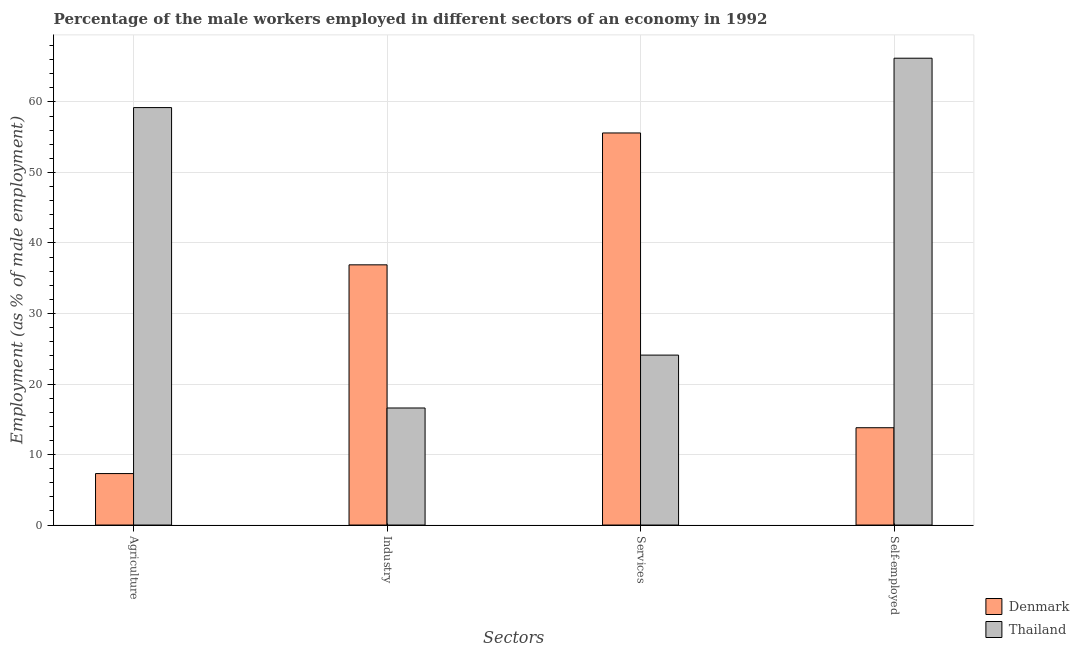How many different coloured bars are there?
Provide a succinct answer. 2. How many groups of bars are there?
Give a very brief answer. 4. Are the number of bars per tick equal to the number of legend labels?
Provide a short and direct response. Yes. Are the number of bars on each tick of the X-axis equal?
Offer a terse response. Yes. What is the label of the 3rd group of bars from the left?
Give a very brief answer. Services. What is the percentage of self employed male workers in Thailand?
Provide a succinct answer. 66.2. Across all countries, what is the maximum percentage of male workers in services?
Your response must be concise. 55.6. Across all countries, what is the minimum percentage of male workers in agriculture?
Your answer should be compact. 7.3. In which country was the percentage of self employed male workers maximum?
Offer a terse response. Thailand. In which country was the percentage of male workers in services minimum?
Your answer should be compact. Thailand. What is the total percentage of male workers in industry in the graph?
Make the answer very short. 53.5. What is the difference between the percentage of male workers in services in Thailand and that in Denmark?
Keep it short and to the point. -31.5. What is the difference between the percentage of male workers in services in Thailand and the percentage of male workers in industry in Denmark?
Give a very brief answer. -12.8. What is the average percentage of male workers in services per country?
Keep it short and to the point. 39.85. What is the difference between the percentage of male workers in services and percentage of male workers in industry in Thailand?
Offer a terse response. 7.5. What is the ratio of the percentage of male workers in services in Thailand to that in Denmark?
Provide a succinct answer. 0.43. Is the difference between the percentage of self employed male workers in Thailand and Denmark greater than the difference between the percentage of male workers in industry in Thailand and Denmark?
Provide a short and direct response. Yes. What is the difference between the highest and the second highest percentage of male workers in agriculture?
Offer a very short reply. 51.9. What is the difference between the highest and the lowest percentage of male workers in industry?
Your response must be concise. 20.3. In how many countries, is the percentage of self employed male workers greater than the average percentage of self employed male workers taken over all countries?
Provide a short and direct response. 1. What does the 1st bar from the left in Self-employed represents?
Provide a short and direct response. Denmark. What does the 1st bar from the right in Agriculture represents?
Offer a very short reply. Thailand. Is it the case that in every country, the sum of the percentage of male workers in agriculture and percentage of male workers in industry is greater than the percentage of male workers in services?
Your response must be concise. No. How many bars are there?
Your answer should be compact. 8. Are all the bars in the graph horizontal?
Make the answer very short. No. What is the difference between two consecutive major ticks on the Y-axis?
Your answer should be compact. 10. Are the values on the major ticks of Y-axis written in scientific E-notation?
Give a very brief answer. No. Does the graph contain any zero values?
Keep it short and to the point. No. Does the graph contain grids?
Offer a very short reply. Yes. Where does the legend appear in the graph?
Keep it short and to the point. Bottom right. How many legend labels are there?
Make the answer very short. 2. What is the title of the graph?
Provide a succinct answer. Percentage of the male workers employed in different sectors of an economy in 1992. Does "Eritrea" appear as one of the legend labels in the graph?
Your answer should be very brief. No. What is the label or title of the X-axis?
Your answer should be very brief. Sectors. What is the label or title of the Y-axis?
Make the answer very short. Employment (as % of male employment). What is the Employment (as % of male employment) in Denmark in Agriculture?
Keep it short and to the point. 7.3. What is the Employment (as % of male employment) of Thailand in Agriculture?
Your answer should be very brief. 59.2. What is the Employment (as % of male employment) in Denmark in Industry?
Your response must be concise. 36.9. What is the Employment (as % of male employment) in Thailand in Industry?
Ensure brevity in your answer.  16.6. What is the Employment (as % of male employment) in Denmark in Services?
Provide a short and direct response. 55.6. What is the Employment (as % of male employment) of Thailand in Services?
Offer a very short reply. 24.1. What is the Employment (as % of male employment) in Denmark in Self-employed?
Offer a terse response. 13.8. What is the Employment (as % of male employment) in Thailand in Self-employed?
Provide a succinct answer. 66.2. Across all Sectors, what is the maximum Employment (as % of male employment) in Denmark?
Make the answer very short. 55.6. Across all Sectors, what is the maximum Employment (as % of male employment) in Thailand?
Offer a terse response. 66.2. Across all Sectors, what is the minimum Employment (as % of male employment) in Denmark?
Make the answer very short. 7.3. Across all Sectors, what is the minimum Employment (as % of male employment) in Thailand?
Offer a terse response. 16.6. What is the total Employment (as % of male employment) of Denmark in the graph?
Give a very brief answer. 113.6. What is the total Employment (as % of male employment) in Thailand in the graph?
Offer a very short reply. 166.1. What is the difference between the Employment (as % of male employment) in Denmark in Agriculture and that in Industry?
Offer a very short reply. -29.6. What is the difference between the Employment (as % of male employment) in Thailand in Agriculture and that in Industry?
Offer a very short reply. 42.6. What is the difference between the Employment (as % of male employment) in Denmark in Agriculture and that in Services?
Give a very brief answer. -48.3. What is the difference between the Employment (as % of male employment) in Thailand in Agriculture and that in Services?
Provide a short and direct response. 35.1. What is the difference between the Employment (as % of male employment) in Denmark in Agriculture and that in Self-employed?
Your answer should be very brief. -6.5. What is the difference between the Employment (as % of male employment) of Denmark in Industry and that in Services?
Your answer should be very brief. -18.7. What is the difference between the Employment (as % of male employment) of Denmark in Industry and that in Self-employed?
Provide a succinct answer. 23.1. What is the difference between the Employment (as % of male employment) in Thailand in Industry and that in Self-employed?
Your response must be concise. -49.6. What is the difference between the Employment (as % of male employment) of Denmark in Services and that in Self-employed?
Offer a terse response. 41.8. What is the difference between the Employment (as % of male employment) of Thailand in Services and that in Self-employed?
Provide a short and direct response. -42.1. What is the difference between the Employment (as % of male employment) in Denmark in Agriculture and the Employment (as % of male employment) in Thailand in Industry?
Provide a short and direct response. -9.3. What is the difference between the Employment (as % of male employment) in Denmark in Agriculture and the Employment (as % of male employment) in Thailand in Services?
Ensure brevity in your answer.  -16.8. What is the difference between the Employment (as % of male employment) of Denmark in Agriculture and the Employment (as % of male employment) of Thailand in Self-employed?
Your answer should be very brief. -58.9. What is the difference between the Employment (as % of male employment) of Denmark in Industry and the Employment (as % of male employment) of Thailand in Self-employed?
Your response must be concise. -29.3. What is the average Employment (as % of male employment) in Denmark per Sectors?
Your answer should be very brief. 28.4. What is the average Employment (as % of male employment) of Thailand per Sectors?
Offer a terse response. 41.52. What is the difference between the Employment (as % of male employment) of Denmark and Employment (as % of male employment) of Thailand in Agriculture?
Offer a terse response. -51.9. What is the difference between the Employment (as % of male employment) in Denmark and Employment (as % of male employment) in Thailand in Industry?
Provide a succinct answer. 20.3. What is the difference between the Employment (as % of male employment) of Denmark and Employment (as % of male employment) of Thailand in Services?
Provide a succinct answer. 31.5. What is the difference between the Employment (as % of male employment) in Denmark and Employment (as % of male employment) in Thailand in Self-employed?
Keep it short and to the point. -52.4. What is the ratio of the Employment (as % of male employment) of Denmark in Agriculture to that in Industry?
Provide a short and direct response. 0.2. What is the ratio of the Employment (as % of male employment) of Thailand in Agriculture to that in Industry?
Your response must be concise. 3.57. What is the ratio of the Employment (as % of male employment) of Denmark in Agriculture to that in Services?
Your answer should be compact. 0.13. What is the ratio of the Employment (as % of male employment) of Thailand in Agriculture to that in Services?
Keep it short and to the point. 2.46. What is the ratio of the Employment (as % of male employment) of Denmark in Agriculture to that in Self-employed?
Offer a terse response. 0.53. What is the ratio of the Employment (as % of male employment) of Thailand in Agriculture to that in Self-employed?
Provide a short and direct response. 0.89. What is the ratio of the Employment (as % of male employment) in Denmark in Industry to that in Services?
Ensure brevity in your answer.  0.66. What is the ratio of the Employment (as % of male employment) of Thailand in Industry to that in Services?
Your answer should be compact. 0.69. What is the ratio of the Employment (as % of male employment) in Denmark in Industry to that in Self-employed?
Provide a succinct answer. 2.67. What is the ratio of the Employment (as % of male employment) in Thailand in Industry to that in Self-employed?
Your response must be concise. 0.25. What is the ratio of the Employment (as % of male employment) of Denmark in Services to that in Self-employed?
Offer a terse response. 4.03. What is the ratio of the Employment (as % of male employment) in Thailand in Services to that in Self-employed?
Keep it short and to the point. 0.36. What is the difference between the highest and the second highest Employment (as % of male employment) in Thailand?
Provide a succinct answer. 7. What is the difference between the highest and the lowest Employment (as % of male employment) of Denmark?
Your answer should be compact. 48.3. What is the difference between the highest and the lowest Employment (as % of male employment) of Thailand?
Your response must be concise. 49.6. 